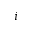Convert formula to latex. <formula><loc_0><loc_0><loc_500><loc_500>i</formula> 